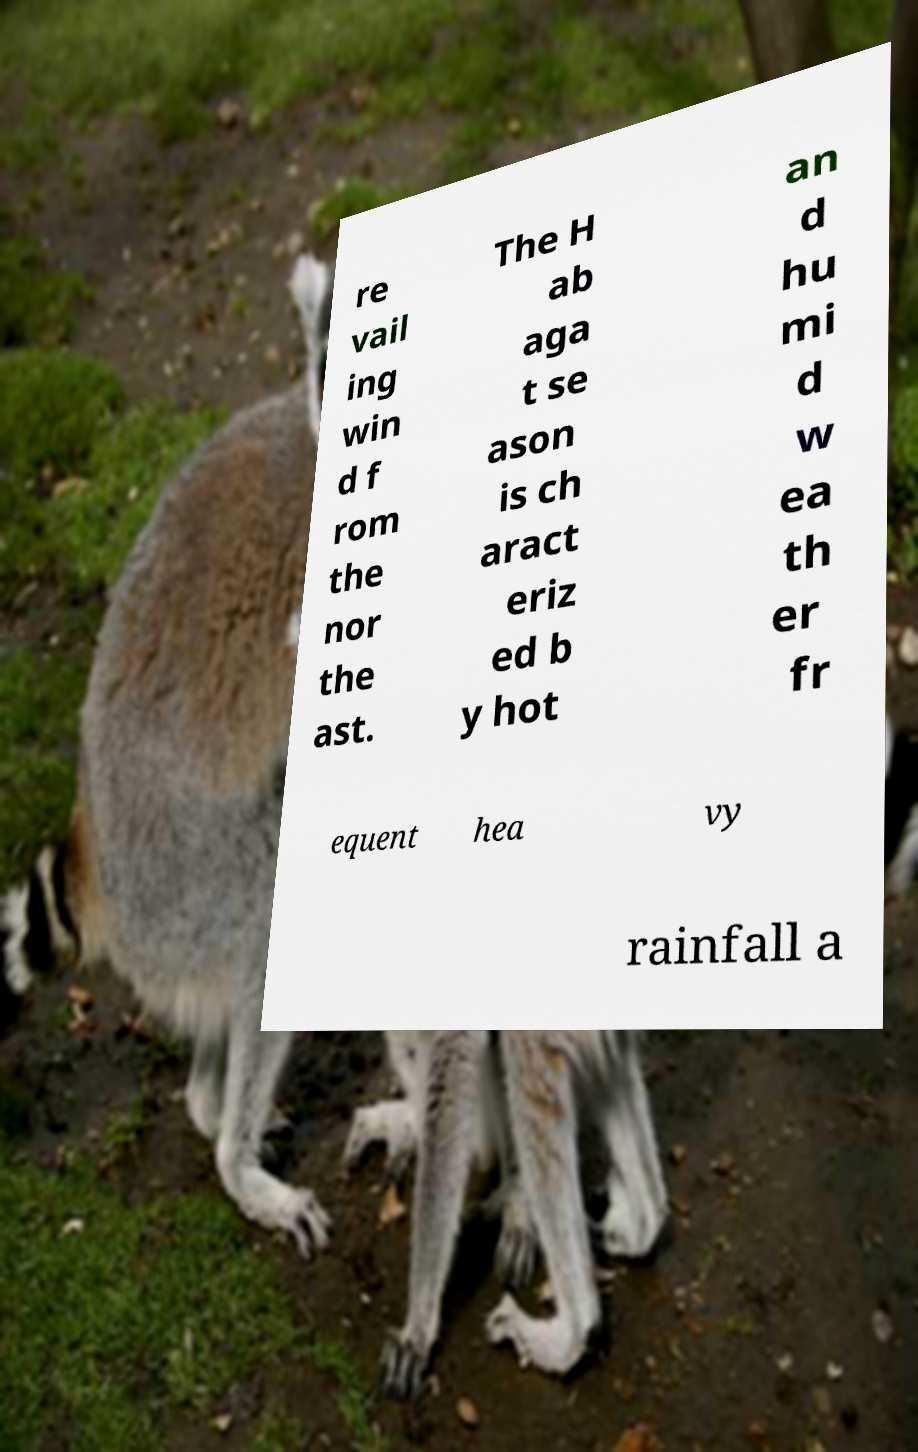Can you accurately transcribe the text from the provided image for me? re vail ing win d f rom the nor the ast. The H ab aga t se ason is ch aract eriz ed b y hot an d hu mi d w ea th er fr equent hea vy rainfall a 